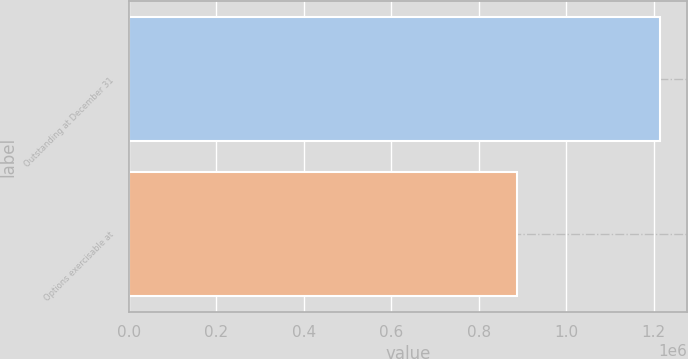<chart> <loc_0><loc_0><loc_500><loc_500><bar_chart><fcel>Outstanding at December 31<fcel>Options exercisable at<nl><fcel>1.21548e+06<fcel>888061<nl></chart> 